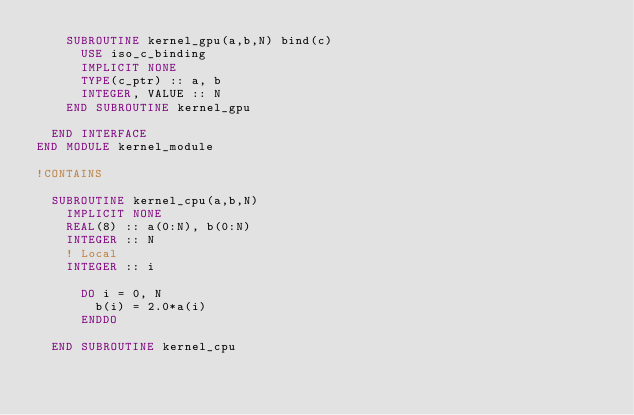Convert code to text. <code><loc_0><loc_0><loc_500><loc_500><_FORTRAN_>    SUBROUTINE kernel_gpu(a,b,N) bind(c)
      USE iso_c_binding
      IMPLICIT NONE
      TYPE(c_ptr) :: a, b
      INTEGER, VALUE :: N
    END SUBROUTINE kernel_gpu

  END INTERFACE
END MODULE kernel_module

!CONTAINS

  SUBROUTINE kernel_cpu(a,b,N)
    IMPLICIT NONE
    REAL(8) :: a(0:N), b(0:N)
    INTEGER :: N
    ! Local
    INTEGER :: i

      DO i = 0, N
        b(i) = 2.0*a(i)
      ENDDO

  END SUBROUTINE kernel_cpu

</code> 